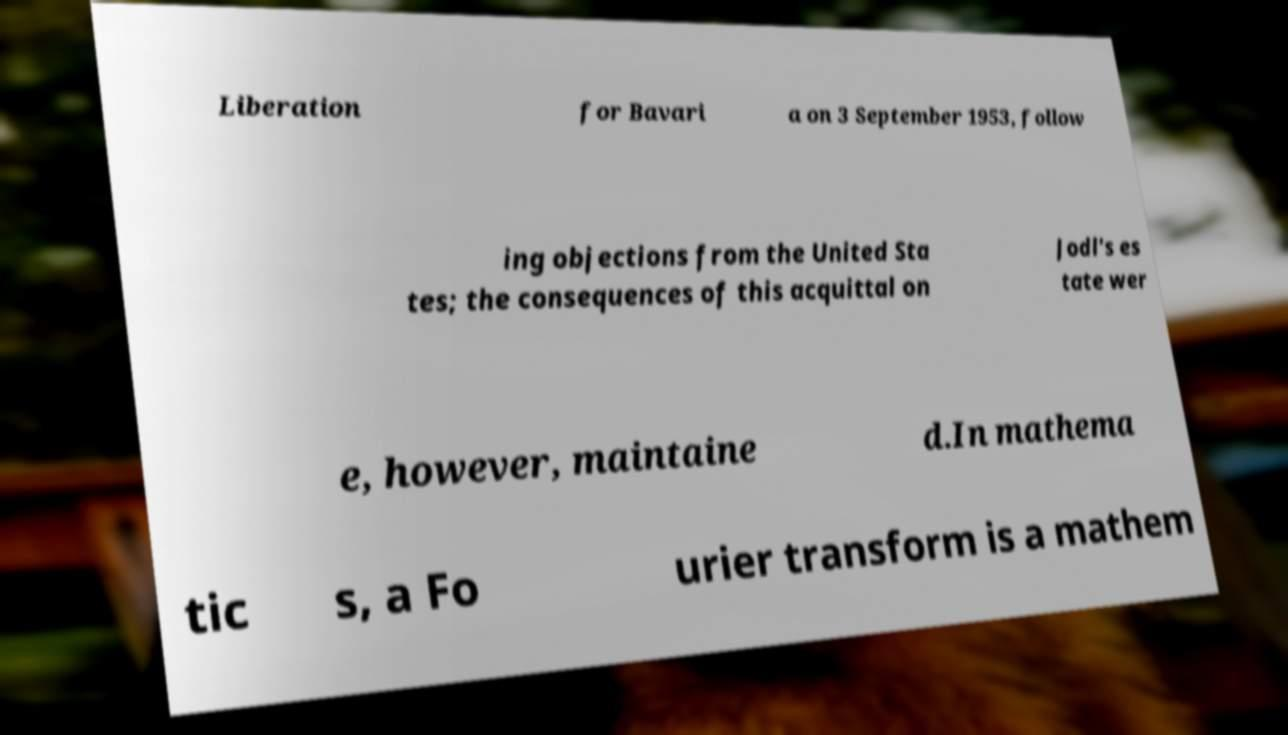Could you extract and type out the text from this image? Liberation for Bavari a on 3 September 1953, follow ing objections from the United Sta tes; the consequences of this acquittal on Jodl's es tate wer e, however, maintaine d.In mathema tic s, a Fo urier transform is a mathem 